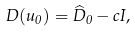<formula> <loc_0><loc_0><loc_500><loc_500>{ D } ( u _ { 0 } ) = \widehat { D } _ { 0 } - c I ,</formula> 